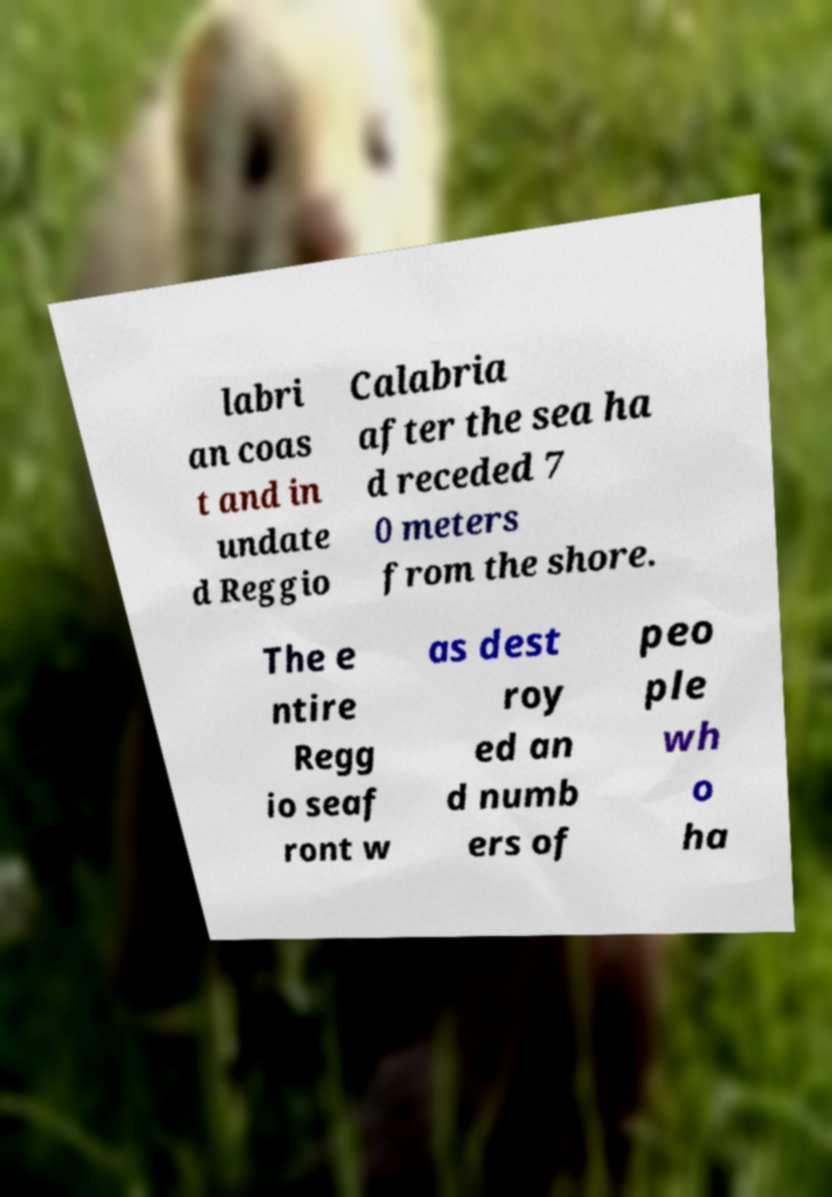Can you accurately transcribe the text from the provided image for me? labri an coas t and in undate d Reggio Calabria after the sea ha d receded 7 0 meters from the shore. The e ntire Regg io seaf ront w as dest roy ed an d numb ers of peo ple wh o ha 